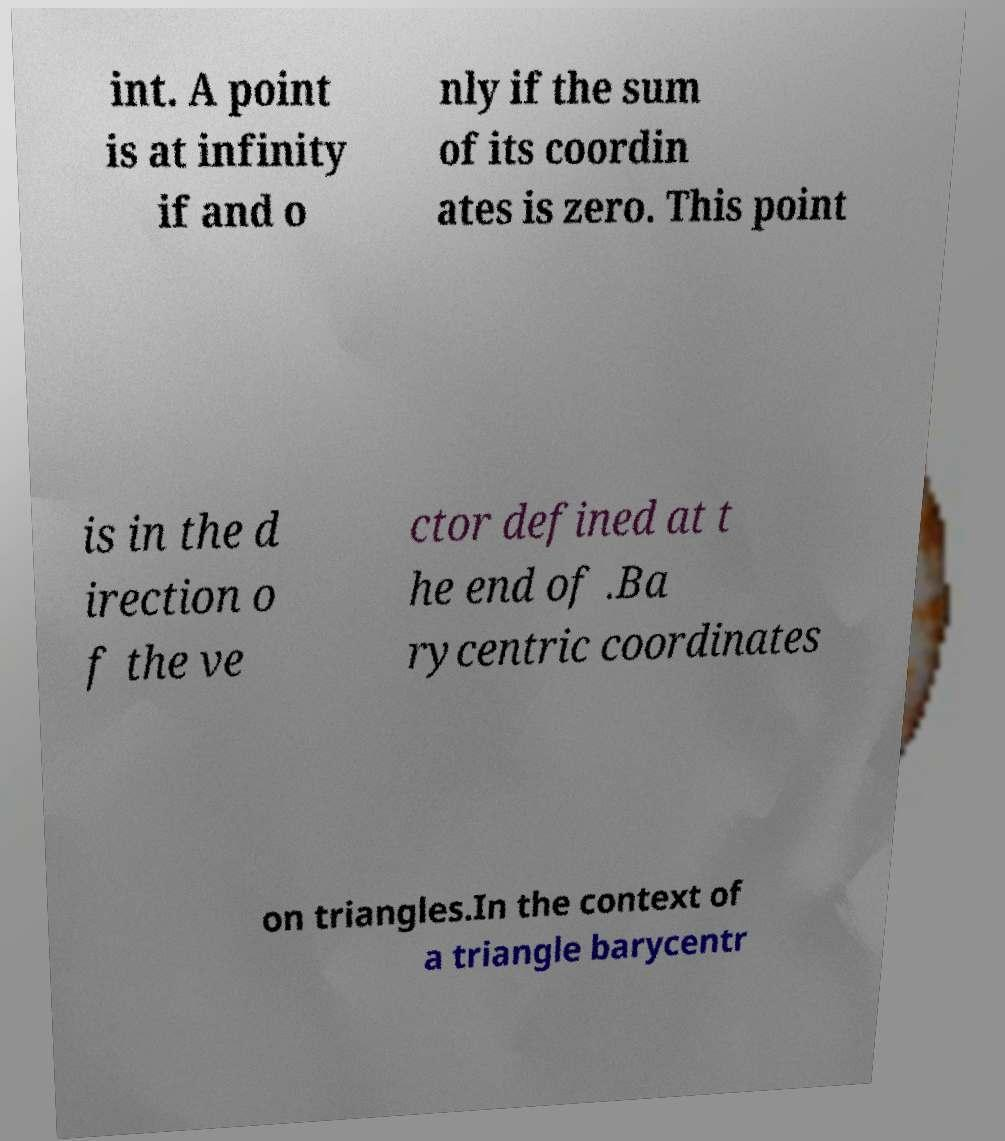Could you extract and type out the text from this image? int. A point is at infinity if and o nly if the sum of its coordin ates is zero. This point is in the d irection o f the ve ctor defined at t he end of .Ba rycentric coordinates on triangles.In the context of a triangle barycentr 